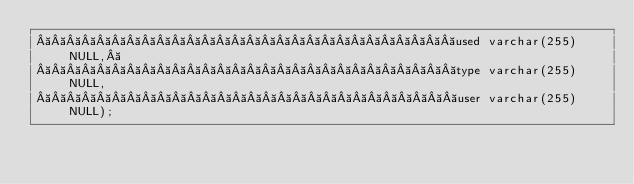Convert code to text. <code><loc_0><loc_0><loc_500><loc_500><_SQL_>                            used varchar(255) NULL, 
                            type varchar(255) NULL,
                            user varchar(255) NULL);
</code> 